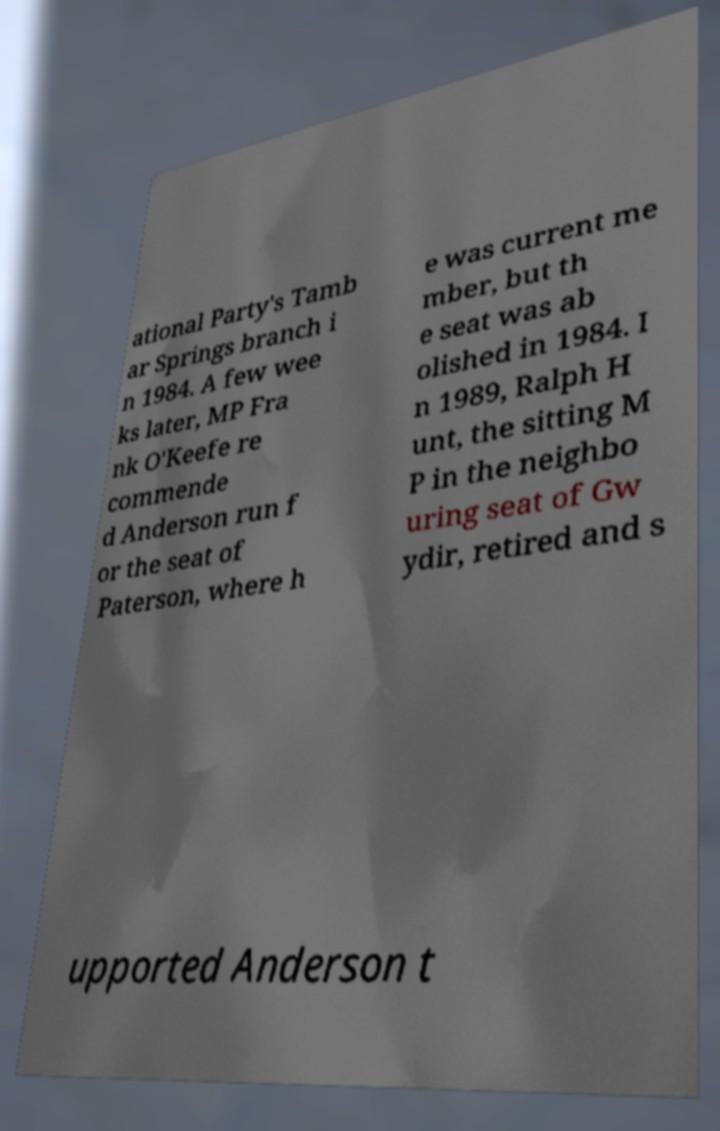For documentation purposes, I need the text within this image transcribed. Could you provide that? ational Party's Tamb ar Springs branch i n 1984. A few wee ks later, MP Fra nk O'Keefe re commende d Anderson run f or the seat of Paterson, where h e was current me mber, but th e seat was ab olished in 1984. I n 1989, Ralph H unt, the sitting M P in the neighbo uring seat of Gw ydir, retired and s upported Anderson t 